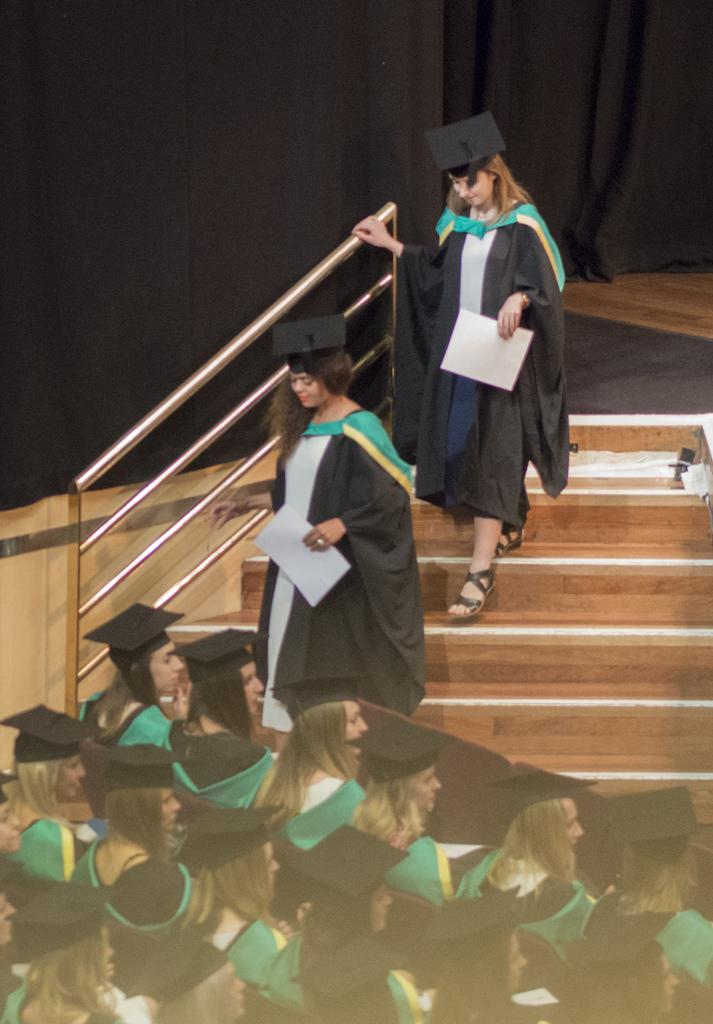Who is present in the image? There are women in the image. What are the women wearing? The women are wearing academic dresses. What can be seen on the left side of the image? There is a railing on the left side of the image. What is the color of the curtains in the background? The curtains in the background are black. What type of hydrant is visible in the image? There is no hydrant present in the image. What are the women talking about in the image? The image does not provide any information about what the women might be talking about. 